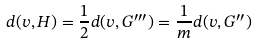Convert formula to latex. <formula><loc_0><loc_0><loc_500><loc_500>d ( v , H ) = \frac { 1 } { 2 } d ( v , G ^ { \prime \prime \prime } ) = \frac { 1 } { m } d ( v , G ^ { \prime \prime } )</formula> 